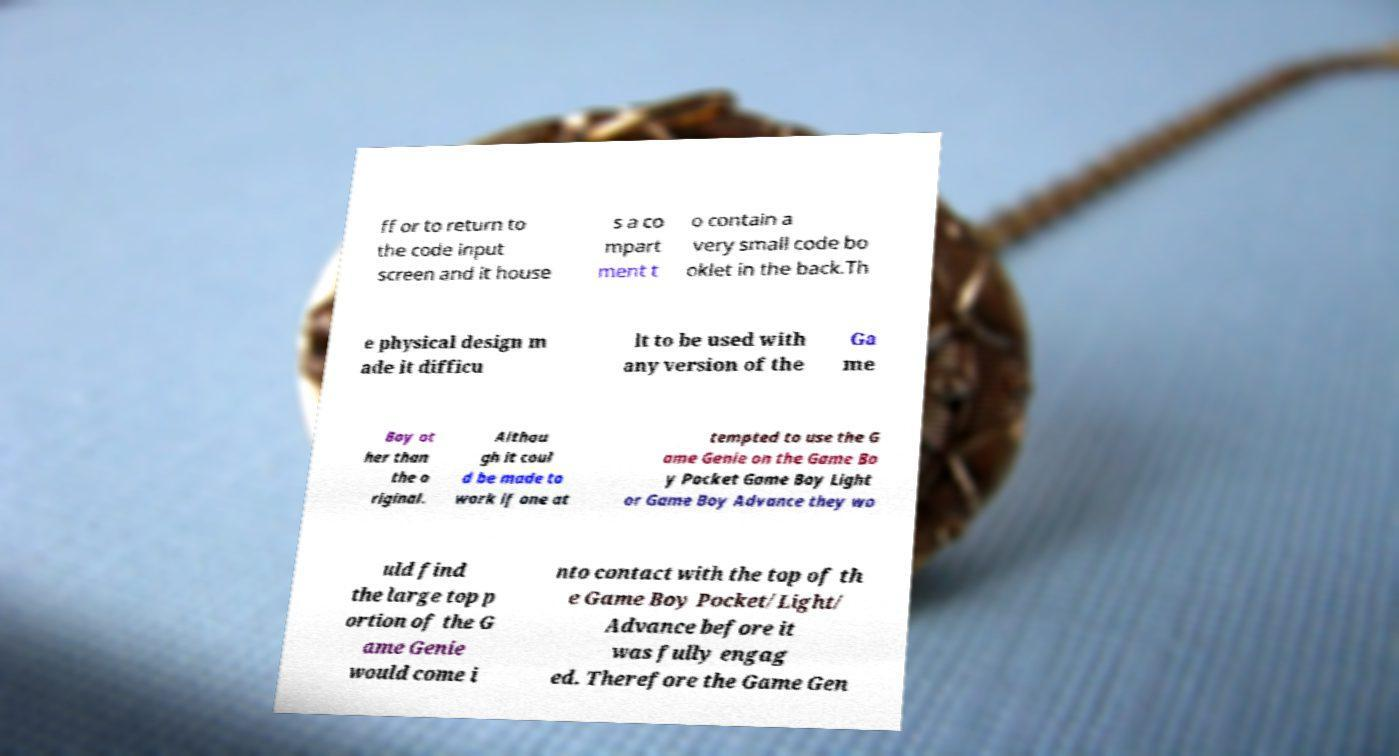Could you extract and type out the text from this image? ff or to return to the code input screen and it house s a co mpart ment t o contain a very small code bo oklet in the back.Th e physical design m ade it difficu lt to be used with any version of the Ga me Boy ot her than the o riginal. Althou gh it coul d be made to work if one at tempted to use the G ame Genie on the Game Bo y Pocket Game Boy Light or Game Boy Advance they wo uld find the large top p ortion of the G ame Genie would come i nto contact with the top of th e Game Boy Pocket/Light/ Advance before it was fully engag ed. Therefore the Game Gen 